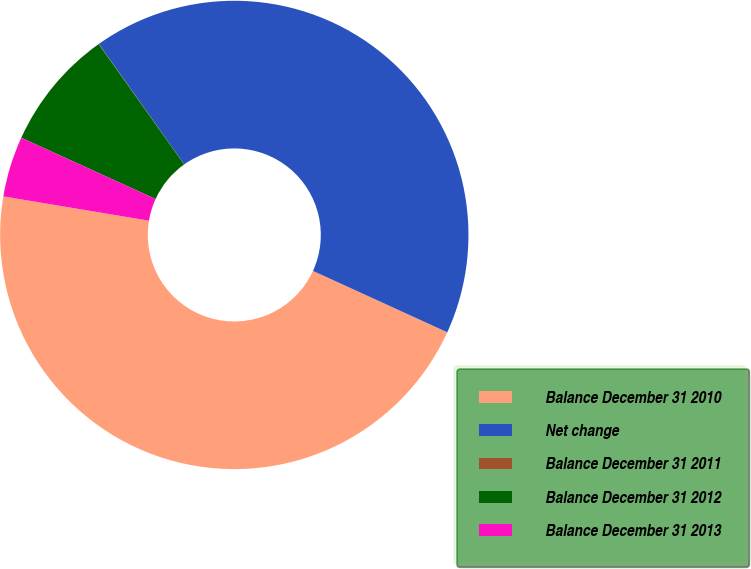Convert chart. <chart><loc_0><loc_0><loc_500><loc_500><pie_chart><fcel>Balance December 31 2010<fcel>Net change<fcel>Balance December 31 2011<fcel>Balance December 31 2012<fcel>Balance December 31 2013<nl><fcel>45.81%<fcel>41.64%<fcel>0.02%<fcel>8.35%<fcel>4.18%<nl></chart> 